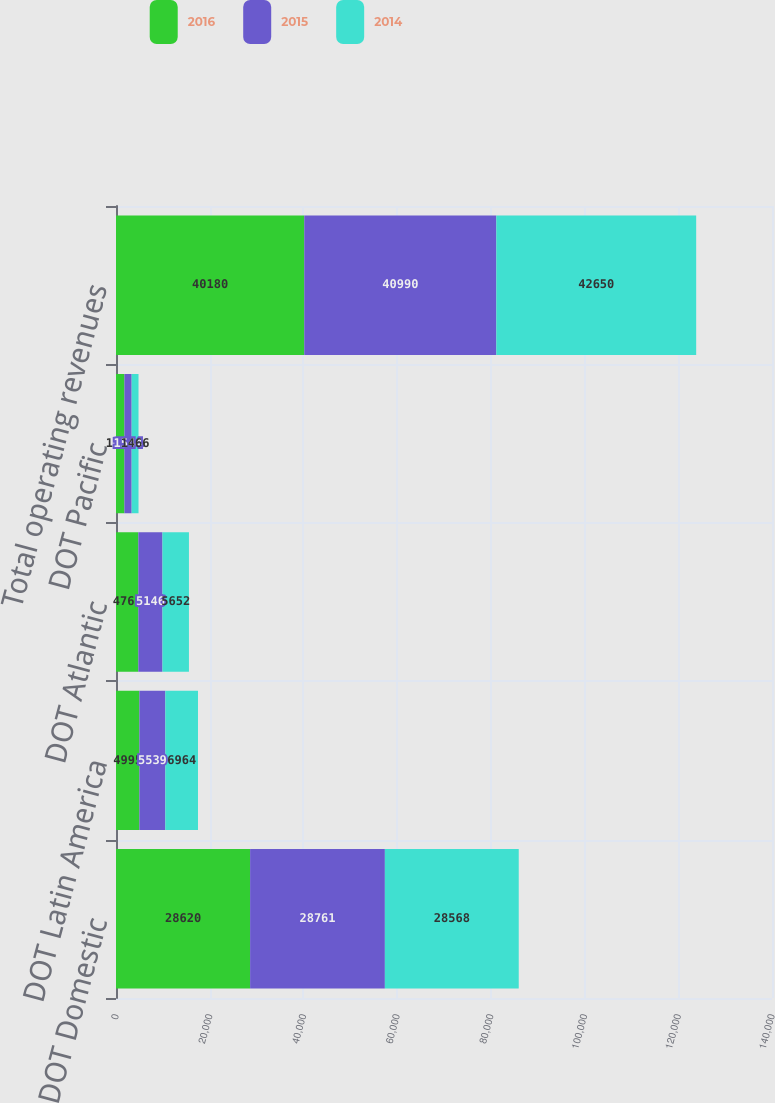Convert chart to OTSL. <chart><loc_0><loc_0><loc_500><loc_500><stacked_bar_chart><ecel><fcel>DOT Domestic<fcel>DOT Latin America<fcel>DOT Atlantic<fcel>DOT Pacific<fcel>Total operating revenues<nl><fcel>2016<fcel>28620<fcel>4995<fcel>4769<fcel>1796<fcel>40180<nl><fcel>2015<fcel>28761<fcel>5539<fcel>5146<fcel>1544<fcel>40990<nl><fcel>2014<fcel>28568<fcel>6964<fcel>5652<fcel>1466<fcel>42650<nl></chart> 